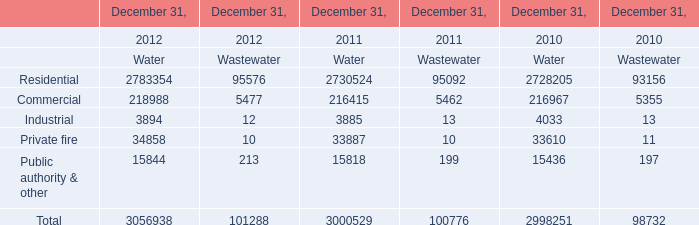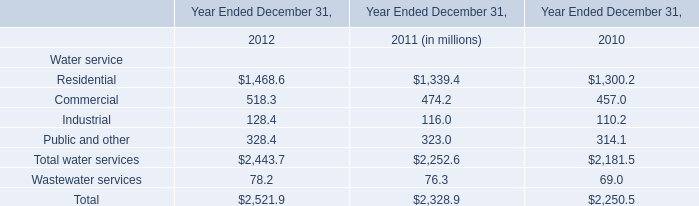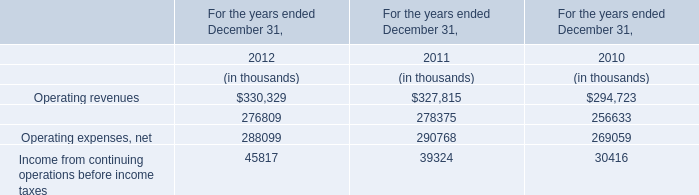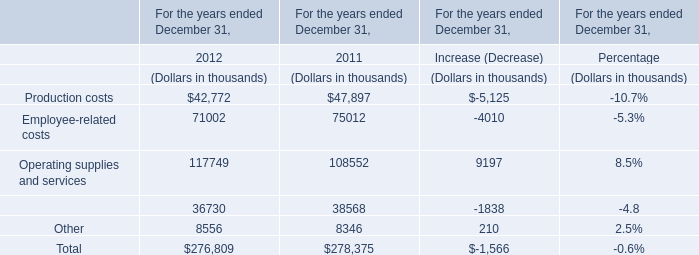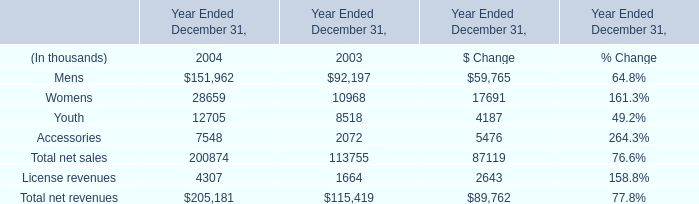The total amount of which section ranks first? (in thousand) 
Answer: 205181. 